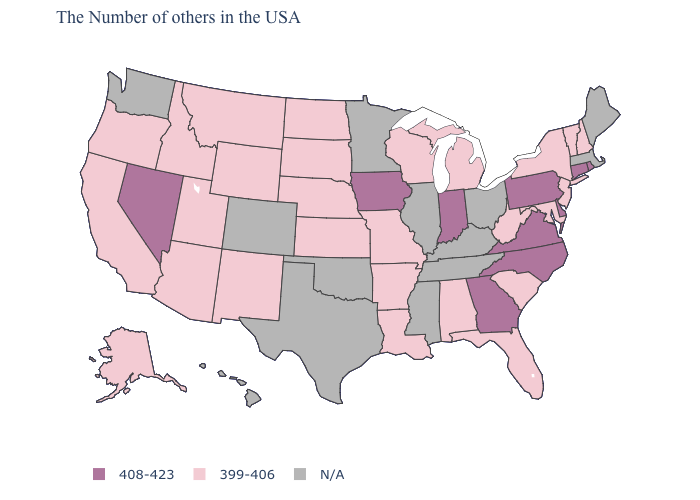Name the states that have a value in the range 408-423?
Write a very short answer. Rhode Island, Connecticut, Delaware, Pennsylvania, Virginia, North Carolina, Georgia, Indiana, Iowa, Nevada. What is the highest value in the USA?
Give a very brief answer. 408-423. What is the value of Pennsylvania?
Short answer required. 408-423. Name the states that have a value in the range 399-406?
Concise answer only. New Hampshire, Vermont, New York, New Jersey, Maryland, South Carolina, West Virginia, Florida, Michigan, Alabama, Wisconsin, Louisiana, Missouri, Arkansas, Kansas, Nebraska, South Dakota, North Dakota, Wyoming, New Mexico, Utah, Montana, Arizona, Idaho, California, Oregon, Alaska. Name the states that have a value in the range N/A?
Short answer required. Maine, Massachusetts, Ohio, Kentucky, Tennessee, Illinois, Mississippi, Minnesota, Oklahoma, Texas, Colorado, Washington, Hawaii. Which states have the lowest value in the USA?
Answer briefly. New Hampshire, Vermont, New York, New Jersey, Maryland, South Carolina, West Virginia, Florida, Michigan, Alabama, Wisconsin, Louisiana, Missouri, Arkansas, Kansas, Nebraska, South Dakota, North Dakota, Wyoming, New Mexico, Utah, Montana, Arizona, Idaho, California, Oregon, Alaska. What is the highest value in the MidWest ?
Be succinct. 408-423. What is the lowest value in states that border Nebraska?
Give a very brief answer. 399-406. Name the states that have a value in the range 399-406?
Write a very short answer. New Hampshire, Vermont, New York, New Jersey, Maryland, South Carolina, West Virginia, Florida, Michigan, Alabama, Wisconsin, Louisiana, Missouri, Arkansas, Kansas, Nebraska, South Dakota, North Dakota, Wyoming, New Mexico, Utah, Montana, Arizona, Idaho, California, Oregon, Alaska. What is the value of California?
Answer briefly. 399-406. Which states have the lowest value in the USA?
Keep it brief. New Hampshire, Vermont, New York, New Jersey, Maryland, South Carolina, West Virginia, Florida, Michigan, Alabama, Wisconsin, Louisiana, Missouri, Arkansas, Kansas, Nebraska, South Dakota, North Dakota, Wyoming, New Mexico, Utah, Montana, Arizona, Idaho, California, Oregon, Alaska. Name the states that have a value in the range N/A?
Keep it brief. Maine, Massachusetts, Ohio, Kentucky, Tennessee, Illinois, Mississippi, Minnesota, Oklahoma, Texas, Colorado, Washington, Hawaii. What is the value of Maryland?
Short answer required. 399-406. What is the value of Nebraska?
Answer briefly. 399-406. 